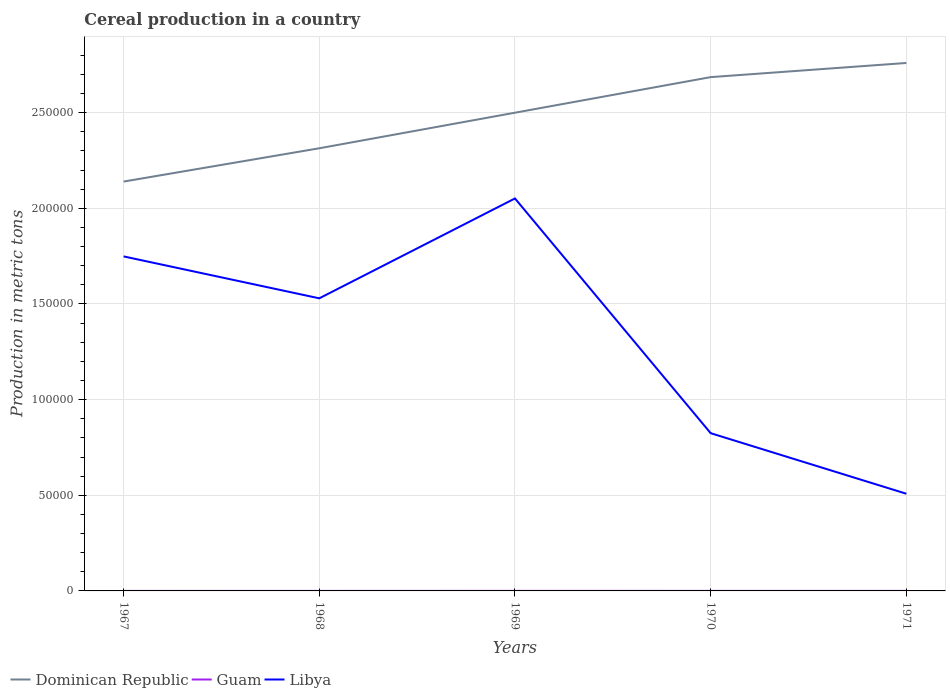How many different coloured lines are there?
Make the answer very short. 3. Does the line corresponding to Libya intersect with the line corresponding to Dominican Republic?
Give a very brief answer. No. Across all years, what is the maximum total cereal production in Dominican Republic?
Keep it short and to the point. 2.14e+05. In which year was the total cereal production in Dominican Republic maximum?
Provide a short and direct response. 1967. What is the total total cereal production in Libya in the graph?
Provide a short and direct response. 7.05e+04. What is the difference between the highest and the second highest total cereal production in Dominican Republic?
Keep it short and to the point. 6.20e+04. What is the difference between the highest and the lowest total cereal production in Libya?
Offer a terse response. 3. Is the total cereal production in Libya strictly greater than the total cereal production in Dominican Republic over the years?
Your answer should be very brief. Yes. What is the difference between two consecutive major ticks on the Y-axis?
Offer a very short reply. 5.00e+04. Are the values on the major ticks of Y-axis written in scientific E-notation?
Your response must be concise. No. Where does the legend appear in the graph?
Your answer should be very brief. Bottom left. What is the title of the graph?
Offer a very short reply. Cereal production in a country. Does "Isle of Man" appear as one of the legend labels in the graph?
Ensure brevity in your answer.  No. What is the label or title of the Y-axis?
Offer a terse response. Production in metric tons. What is the Production in metric tons of Dominican Republic in 1967?
Give a very brief answer. 2.14e+05. What is the Production in metric tons in Libya in 1967?
Offer a very short reply. 1.75e+05. What is the Production in metric tons in Dominican Republic in 1968?
Your answer should be very brief. 2.31e+05. What is the Production in metric tons of Libya in 1968?
Offer a very short reply. 1.53e+05. What is the Production in metric tons of Dominican Republic in 1969?
Your answer should be very brief. 2.50e+05. What is the Production in metric tons in Guam in 1969?
Keep it short and to the point. 31. What is the Production in metric tons of Libya in 1969?
Keep it short and to the point. 2.05e+05. What is the Production in metric tons of Dominican Republic in 1970?
Your answer should be very brief. 2.69e+05. What is the Production in metric tons in Libya in 1970?
Your answer should be compact. 8.25e+04. What is the Production in metric tons in Dominican Republic in 1971?
Provide a succinct answer. 2.76e+05. What is the Production in metric tons of Guam in 1971?
Your answer should be very brief. 25. What is the Production in metric tons in Libya in 1971?
Give a very brief answer. 5.08e+04. Across all years, what is the maximum Production in metric tons of Dominican Republic?
Offer a very short reply. 2.76e+05. Across all years, what is the maximum Production in metric tons in Libya?
Offer a terse response. 2.05e+05. Across all years, what is the minimum Production in metric tons in Dominican Republic?
Provide a succinct answer. 2.14e+05. Across all years, what is the minimum Production in metric tons of Libya?
Provide a succinct answer. 5.08e+04. What is the total Production in metric tons in Dominican Republic in the graph?
Provide a short and direct response. 1.24e+06. What is the total Production in metric tons in Guam in the graph?
Keep it short and to the point. 103. What is the total Production in metric tons in Libya in the graph?
Provide a short and direct response. 6.66e+05. What is the difference between the Production in metric tons in Dominican Republic in 1967 and that in 1968?
Give a very brief answer. -1.74e+04. What is the difference between the Production in metric tons of Libya in 1967 and that in 1968?
Your answer should be very brief. 2.19e+04. What is the difference between the Production in metric tons of Dominican Republic in 1967 and that in 1969?
Your answer should be compact. -3.60e+04. What is the difference between the Production in metric tons of Libya in 1967 and that in 1969?
Your answer should be very brief. -3.03e+04. What is the difference between the Production in metric tons in Dominican Republic in 1967 and that in 1970?
Offer a terse response. -5.46e+04. What is the difference between the Production in metric tons of Guam in 1967 and that in 1970?
Keep it short and to the point. -13. What is the difference between the Production in metric tons in Libya in 1967 and that in 1970?
Offer a terse response. 9.24e+04. What is the difference between the Production in metric tons of Dominican Republic in 1967 and that in 1971?
Offer a terse response. -6.20e+04. What is the difference between the Production in metric tons of Libya in 1967 and that in 1971?
Your answer should be very brief. 1.24e+05. What is the difference between the Production in metric tons in Dominican Republic in 1968 and that in 1969?
Your response must be concise. -1.86e+04. What is the difference between the Production in metric tons of Guam in 1968 and that in 1969?
Your answer should be very brief. -17. What is the difference between the Production in metric tons of Libya in 1968 and that in 1969?
Ensure brevity in your answer.  -5.22e+04. What is the difference between the Production in metric tons of Dominican Republic in 1968 and that in 1970?
Ensure brevity in your answer.  -3.72e+04. What is the difference between the Production in metric tons in Guam in 1968 and that in 1970?
Your answer should be very brief. -9. What is the difference between the Production in metric tons of Libya in 1968 and that in 1970?
Your answer should be compact. 7.05e+04. What is the difference between the Production in metric tons in Dominican Republic in 1968 and that in 1971?
Your answer should be very brief. -4.46e+04. What is the difference between the Production in metric tons in Guam in 1968 and that in 1971?
Give a very brief answer. -11. What is the difference between the Production in metric tons of Libya in 1968 and that in 1971?
Your answer should be very brief. 1.02e+05. What is the difference between the Production in metric tons in Dominican Republic in 1969 and that in 1970?
Ensure brevity in your answer.  -1.86e+04. What is the difference between the Production in metric tons of Guam in 1969 and that in 1970?
Your answer should be very brief. 8. What is the difference between the Production in metric tons of Libya in 1969 and that in 1970?
Keep it short and to the point. 1.23e+05. What is the difference between the Production in metric tons in Dominican Republic in 1969 and that in 1971?
Your response must be concise. -2.60e+04. What is the difference between the Production in metric tons in Libya in 1969 and that in 1971?
Keep it short and to the point. 1.54e+05. What is the difference between the Production in metric tons in Dominican Republic in 1970 and that in 1971?
Keep it short and to the point. -7400. What is the difference between the Production in metric tons of Libya in 1970 and that in 1971?
Your answer should be compact. 3.17e+04. What is the difference between the Production in metric tons in Dominican Republic in 1967 and the Production in metric tons in Guam in 1968?
Your answer should be compact. 2.14e+05. What is the difference between the Production in metric tons of Dominican Republic in 1967 and the Production in metric tons of Libya in 1968?
Offer a terse response. 6.10e+04. What is the difference between the Production in metric tons in Guam in 1967 and the Production in metric tons in Libya in 1968?
Offer a very short reply. -1.53e+05. What is the difference between the Production in metric tons of Dominican Republic in 1967 and the Production in metric tons of Guam in 1969?
Make the answer very short. 2.14e+05. What is the difference between the Production in metric tons of Dominican Republic in 1967 and the Production in metric tons of Libya in 1969?
Your response must be concise. 8826. What is the difference between the Production in metric tons of Guam in 1967 and the Production in metric tons of Libya in 1969?
Keep it short and to the point. -2.05e+05. What is the difference between the Production in metric tons of Dominican Republic in 1967 and the Production in metric tons of Guam in 1970?
Keep it short and to the point. 2.14e+05. What is the difference between the Production in metric tons in Dominican Republic in 1967 and the Production in metric tons in Libya in 1970?
Your answer should be very brief. 1.32e+05. What is the difference between the Production in metric tons in Guam in 1967 and the Production in metric tons in Libya in 1970?
Provide a short and direct response. -8.24e+04. What is the difference between the Production in metric tons in Dominican Republic in 1967 and the Production in metric tons in Guam in 1971?
Your response must be concise. 2.14e+05. What is the difference between the Production in metric tons of Dominican Republic in 1967 and the Production in metric tons of Libya in 1971?
Your answer should be compact. 1.63e+05. What is the difference between the Production in metric tons in Guam in 1967 and the Production in metric tons in Libya in 1971?
Provide a succinct answer. -5.08e+04. What is the difference between the Production in metric tons of Dominican Republic in 1968 and the Production in metric tons of Guam in 1969?
Keep it short and to the point. 2.31e+05. What is the difference between the Production in metric tons in Dominican Republic in 1968 and the Production in metric tons in Libya in 1969?
Ensure brevity in your answer.  2.62e+04. What is the difference between the Production in metric tons of Guam in 1968 and the Production in metric tons of Libya in 1969?
Keep it short and to the point. -2.05e+05. What is the difference between the Production in metric tons of Dominican Republic in 1968 and the Production in metric tons of Guam in 1970?
Offer a very short reply. 2.31e+05. What is the difference between the Production in metric tons of Dominican Republic in 1968 and the Production in metric tons of Libya in 1970?
Your answer should be very brief. 1.49e+05. What is the difference between the Production in metric tons of Guam in 1968 and the Production in metric tons of Libya in 1970?
Provide a short and direct response. -8.24e+04. What is the difference between the Production in metric tons of Dominican Republic in 1968 and the Production in metric tons of Guam in 1971?
Provide a succinct answer. 2.31e+05. What is the difference between the Production in metric tons of Dominican Republic in 1968 and the Production in metric tons of Libya in 1971?
Give a very brief answer. 1.81e+05. What is the difference between the Production in metric tons in Guam in 1968 and the Production in metric tons in Libya in 1971?
Your answer should be compact. -5.08e+04. What is the difference between the Production in metric tons in Dominican Republic in 1969 and the Production in metric tons in Guam in 1970?
Provide a short and direct response. 2.50e+05. What is the difference between the Production in metric tons of Dominican Republic in 1969 and the Production in metric tons of Libya in 1970?
Make the answer very short. 1.68e+05. What is the difference between the Production in metric tons in Guam in 1969 and the Production in metric tons in Libya in 1970?
Your answer should be compact. -8.24e+04. What is the difference between the Production in metric tons of Dominican Republic in 1969 and the Production in metric tons of Guam in 1971?
Provide a succinct answer. 2.50e+05. What is the difference between the Production in metric tons in Dominican Republic in 1969 and the Production in metric tons in Libya in 1971?
Give a very brief answer. 1.99e+05. What is the difference between the Production in metric tons of Guam in 1969 and the Production in metric tons of Libya in 1971?
Provide a succinct answer. -5.08e+04. What is the difference between the Production in metric tons in Dominican Republic in 1970 and the Production in metric tons in Guam in 1971?
Your answer should be very brief. 2.69e+05. What is the difference between the Production in metric tons in Dominican Republic in 1970 and the Production in metric tons in Libya in 1971?
Provide a short and direct response. 2.18e+05. What is the difference between the Production in metric tons of Guam in 1970 and the Production in metric tons of Libya in 1971?
Your answer should be very brief. -5.08e+04. What is the average Production in metric tons of Dominican Republic per year?
Give a very brief answer. 2.48e+05. What is the average Production in metric tons in Guam per year?
Give a very brief answer. 20.6. What is the average Production in metric tons of Libya per year?
Your response must be concise. 1.33e+05. In the year 1967, what is the difference between the Production in metric tons in Dominican Republic and Production in metric tons in Guam?
Provide a short and direct response. 2.14e+05. In the year 1967, what is the difference between the Production in metric tons in Dominican Republic and Production in metric tons in Libya?
Offer a very short reply. 3.91e+04. In the year 1967, what is the difference between the Production in metric tons of Guam and Production in metric tons of Libya?
Give a very brief answer. -1.75e+05. In the year 1968, what is the difference between the Production in metric tons in Dominican Republic and Production in metric tons in Guam?
Make the answer very short. 2.31e+05. In the year 1968, what is the difference between the Production in metric tons in Dominican Republic and Production in metric tons in Libya?
Ensure brevity in your answer.  7.84e+04. In the year 1968, what is the difference between the Production in metric tons in Guam and Production in metric tons in Libya?
Make the answer very short. -1.53e+05. In the year 1969, what is the difference between the Production in metric tons in Dominican Republic and Production in metric tons in Guam?
Make the answer very short. 2.50e+05. In the year 1969, what is the difference between the Production in metric tons of Dominican Republic and Production in metric tons of Libya?
Your response must be concise. 4.48e+04. In the year 1969, what is the difference between the Production in metric tons in Guam and Production in metric tons in Libya?
Your answer should be compact. -2.05e+05. In the year 1970, what is the difference between the Production in metric tons in Dominican Republic and Production in metric tons in Guam?
Make the answer very short. 2.69e+05. In the year 1970, what is the difference between the Production in metric tons in Dominican Republic and Production in metric tons in Libya?
Your answer should be very brief. 1.86e+05. In the year 1970, what is the difference between the Production in metric tons in Guam and Production in metric tons in Libya?
Your response must be concise. -8.24e+04. In the year 1971, what is the difference between the Production in metric tons of Dominican Republic and Production in metric tons of Guam?
Offer a terse response. 2.76e+05. In the year 1971, what is the difference between the Production in metric tons of Dominican Republic and Production in metric tons of Libya?
Your response must be concise. 2.25e+05. In the year 1971, what is the difference between the Production in metric tons of Guam and Production in metric tons of Libya?
Give a very brief answer. -5.08e+04. What is the ratio of the Production in metric tons in Dominican Republic in 1967 to that in 1968?
Keep it short and to the point. 0.92. What is the ratio of the Production in metric tons in Libya in 1967 to that in 1968?
Ensure brevity in your answer.  1.14. What is the ratio of the Production in metric tons of Dominican Republic in 1967 to that in 1969?
Give a very brief answer. 0.86. What is the ratio of the Production in metric tons of Guam in 1967 to that in 1969?
Your answer should be compact. 0.32. What is the ratio of the Production in metric tons in Libya in 1967 to that in 1969?
Keep it short and to the point. 0.85. What is the ratio of the Production in metric tons in Dominican Republic in 1967 to that in 1970?
Offer a very short reply. 0.8. What is the ratio of the Production in metric tons in Guam in 1967 to that in 1970?
Offer a terse response. 0.43. What is the ratio of the Production in metric tons of Libya in 1967 to that in 1970?
Ensure brevity in your answer.  2.12. What is the ratio of the Production in metric tons of Dominican Republic in 1967 to that in 1971?
Ensure brevity in your answer.  0.78. What is the ratio of the Production in metric tons in Guam in 1967 to that in 1971?
Your response must be concise. 0.4. What is the ratio of the Production in metric tons in Libya in 1967 to that in 1971?
Ensure brevity in your answer.  3.44. What is the ratio of the Production in metric tons of Dominican Republic in 1968 to that in 1969?
Make the answer very short. 0.93. What is the ratio of the Production in metric tons of Guam in 1968 to that in 1969?
Ensure brevity in your answer.  0.45. What is the ratio of the Production in metric tons in Libya in 1968 to that in 1969?
Ensure brevity in your answer.  0.75. What is the ratio of the Production in metric tons of Dominican Republic in 1968 to that in 1970?
Ensure brevity in your answer.  0.86. What is the ratio of the Production in metric tons in Guam in 1968 to that in 1970?
Ensure brevity in your answer.  0.61. What is the ratio of the Production in metric tons of Libya in 1968 to that in 1970?
Keep it short and to the point. 1.85. What is the ratio of the Production in metric tons in Dominican Republic in 1968 to that in 1971?
Ensure brevity in your answer.  0.84. What is the ratio of the Production in metric tons of Guam in 1968 to that in 1971?
Make the answer very short. 0.56. What is the ratio of the Production in metric tons of Libya in 1968 to that in 1971?
Your answer should be very brief. 3.01. What is the ratio of the Production in metric tons in Dominican Republic in 1969 to that in 1970?
Offer a terse response. 0.93. What is the ratio of the Production in metric tons in Guam in 1969 to that in 1970?
Give a very brief answer. 1.35. What is the ratio of the Production in metric tons of Libya in 1969 to that in 1970?
Keep it short and to the point. 2.49. What is the ratio of the Production in metric tons of Dominican Republic in 1969 to that in 1971?
Make the answer very short. 0.91. What is the ratio of the Production in metric tons in Guam in 1969 to that in 1971?
Provide a short and direct response. 1.24. What is the ratio of the Production in metric tons of Libya in 1969 to that in 1971?
Provide a succinct answer. 4.04. What is the ratio of the Production in metric tons of Dominican Republic in 1970 to that in 1971?
Provide a short and direct response. 0.97. What is the ratio of the Production in metric tons in Guam in 1970 to that in 1971?
Keep it short and to the point. 0.92. What is the ratio of the Production in metric tons of Libya in 1970 to that in 1971?
Give a very brief answer. 1.62. What is the difference between the highest and the second highest Production in metric tons in Dominican Republic?
Your response must be concise. 7400. What is the difference between the highest and the second highest Production in metric tons in Libya?
Provide a succinct answer. 3.03e+04. What is the difference between the highest and the lowest Production in metric tons in Dominican Republic?
Your answer should be very brief. 6.20e+04. What is the difference between the highest and the lowest Production in metric tons of Guam?
Your answer should be very brief. 21. What is the difference between the highest and the lowest Production in metric tons of Libya?
Offer a very short reply. 1.54e+05. 